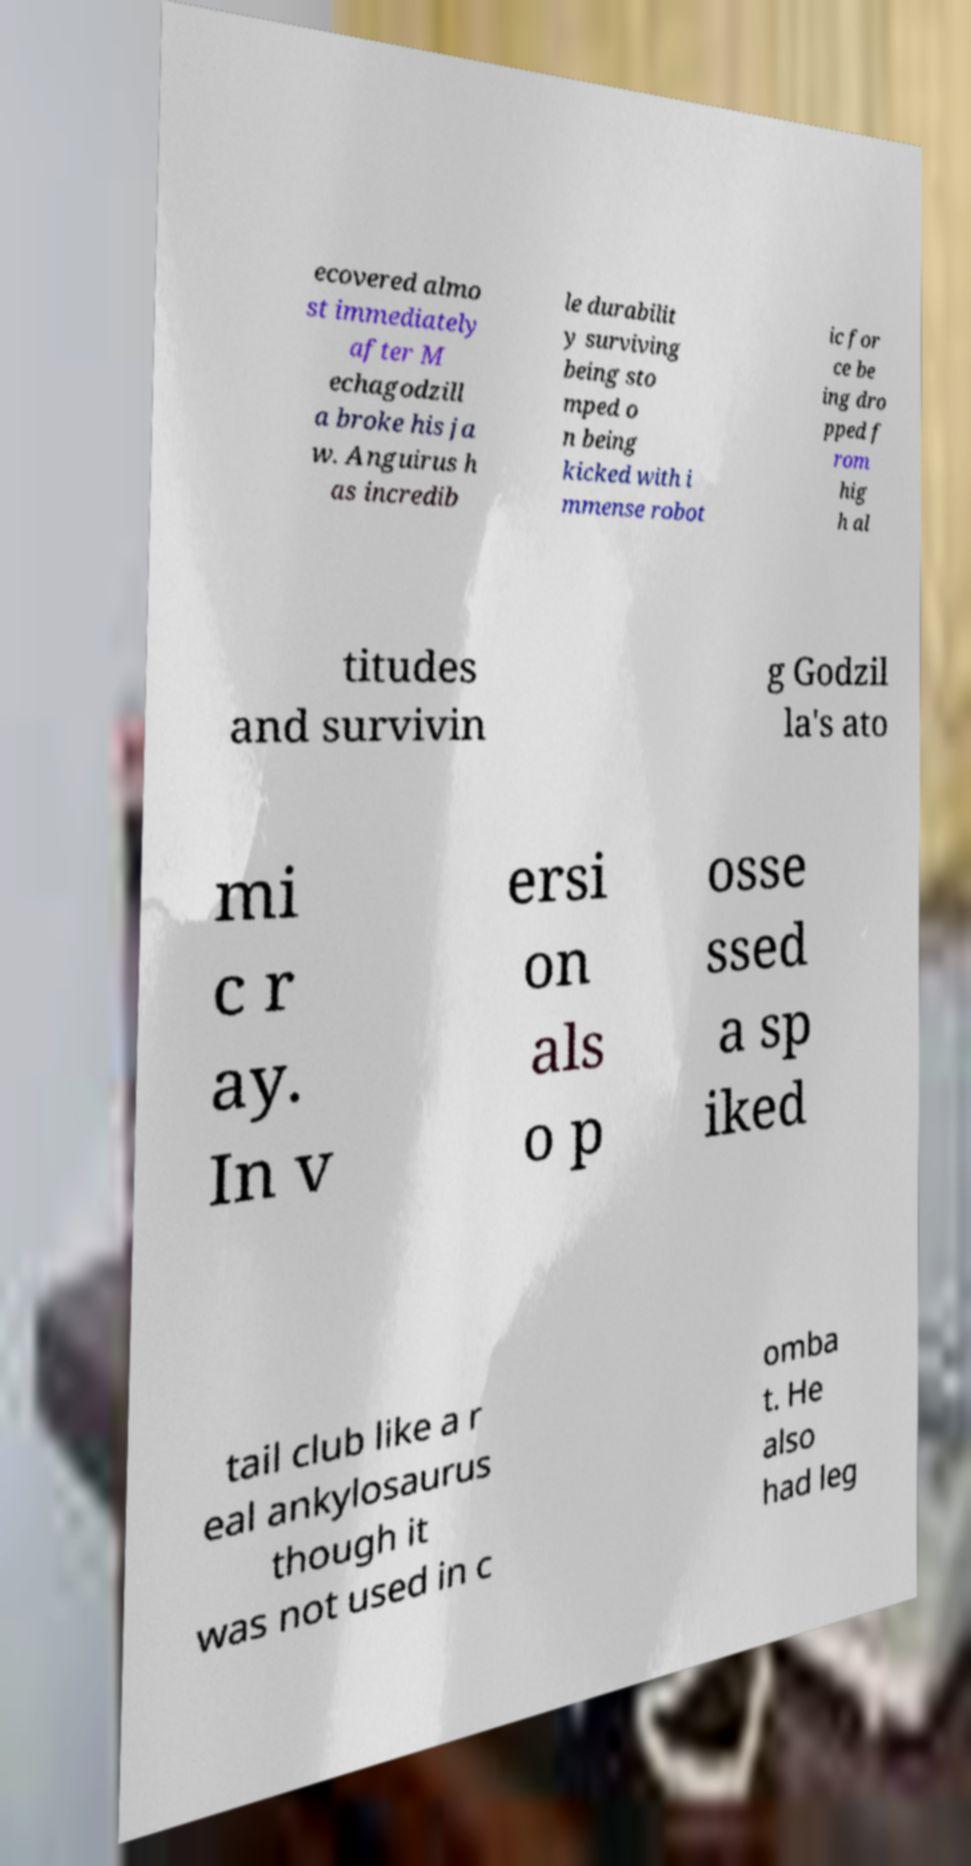Can you read and provide the text displayed in the image?This photo seems to have some interesting text. Can you extract and type it out for me? ecovered almo st immediately after M echagodzill a broke his ja w. Anguirus h as incredib le durabilit y surviving being sto mped o n being kicked with i mmense robot ic for ce be ing dro pped f rom hig h al titudes and survivin g Godzil la's ato mi c r ay. In v ersi on als o p osse ssed a sp iked tail club like a r eal ankylosaurus though it was not used in c omba t. He also had leg 